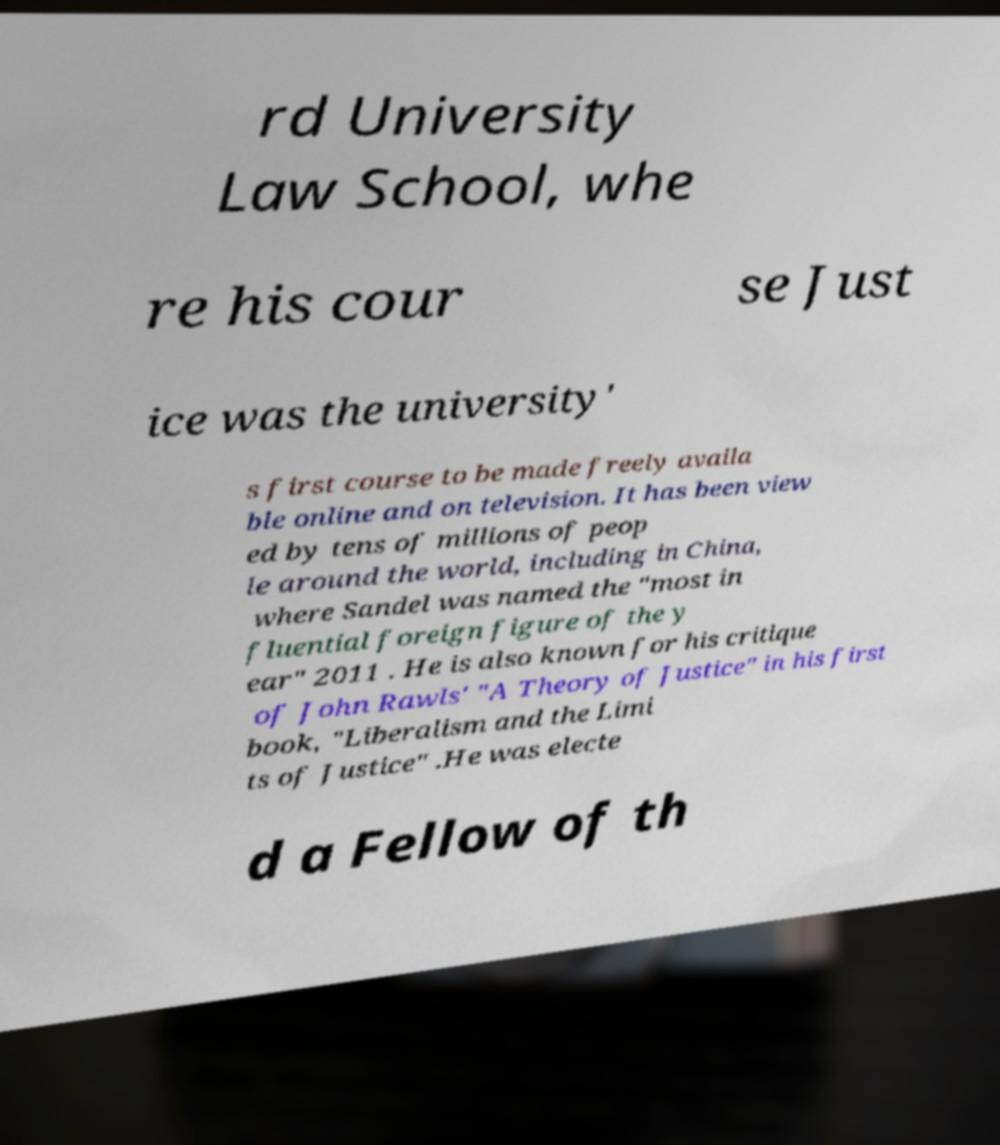What messages or text are displayed in this image? I need them in a readable, typed format. rd University Law School, whe re his cour se Just ice was the university' s first course to be made freely availa ble online and on television. It has been view ed by tens of millions of peop le around the world, including in China, where Sandel was named the "most in fluential foreign figure of the y ear" 2011 . He is also known for his critique of John Rawls' "A Theory of Justice" in his first book, "Liberalism and the Limi ts of Justice" .He was electe d a Fellow of th 